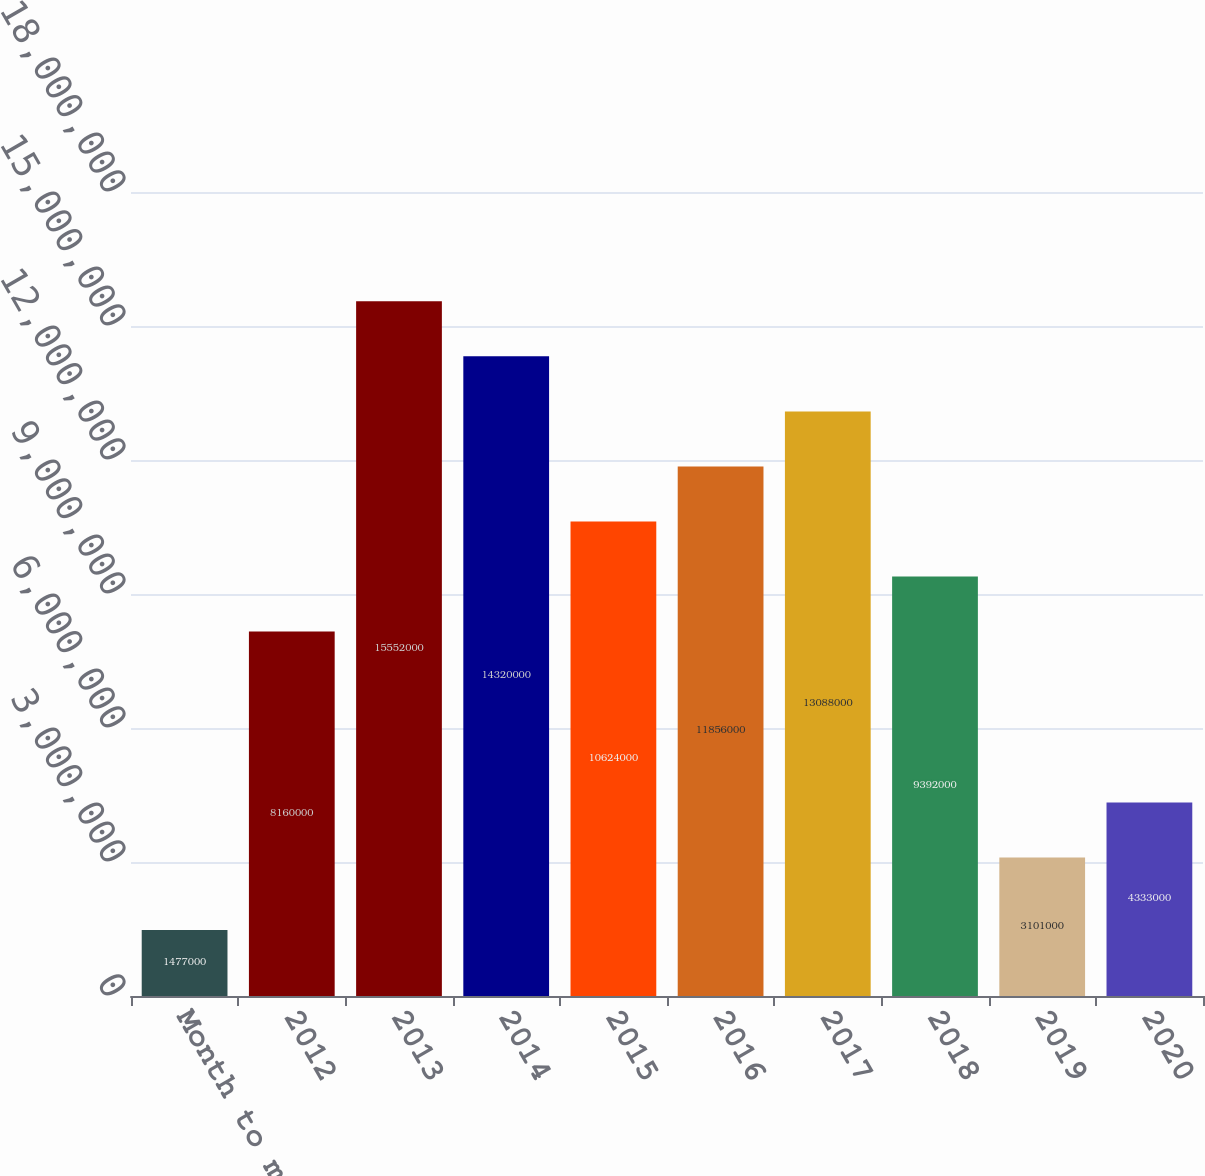<chart> <loc_0><loc_0><loc_500><loc_500><bar_chart><fcel>Month to month<fcel>2012<fcel>2013<fcel>2014<fcel>2015<fcel>2016<fcel>2017<fcel>2018<fcel>2019<fcel>2020<nl><fcel>1.477e+06<fcel>8.16e+06<fcel>1.5552e+07<fcel>1.432e+07<fcel>1.0624e+07<fcel>1.1856e+07<fcel>1.3088e+07<fcel>9.392e+06<fcel>3.101e+06<fcel>4.333e+06<nl></chart> 